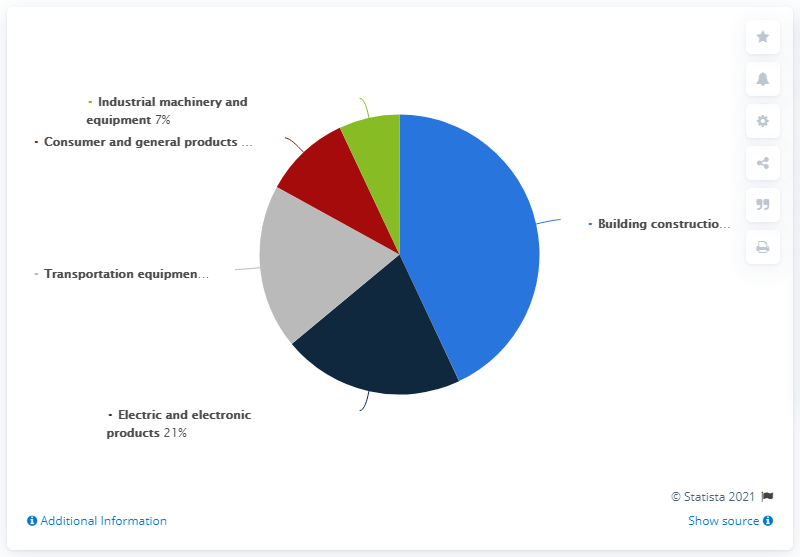Indicate a few pertinent items in this graphic. Based on the information provided, the total sum of electric and electronic products, and industrial machinery and equipment is 28. The red color in the pie chart represents consumer and general products. 